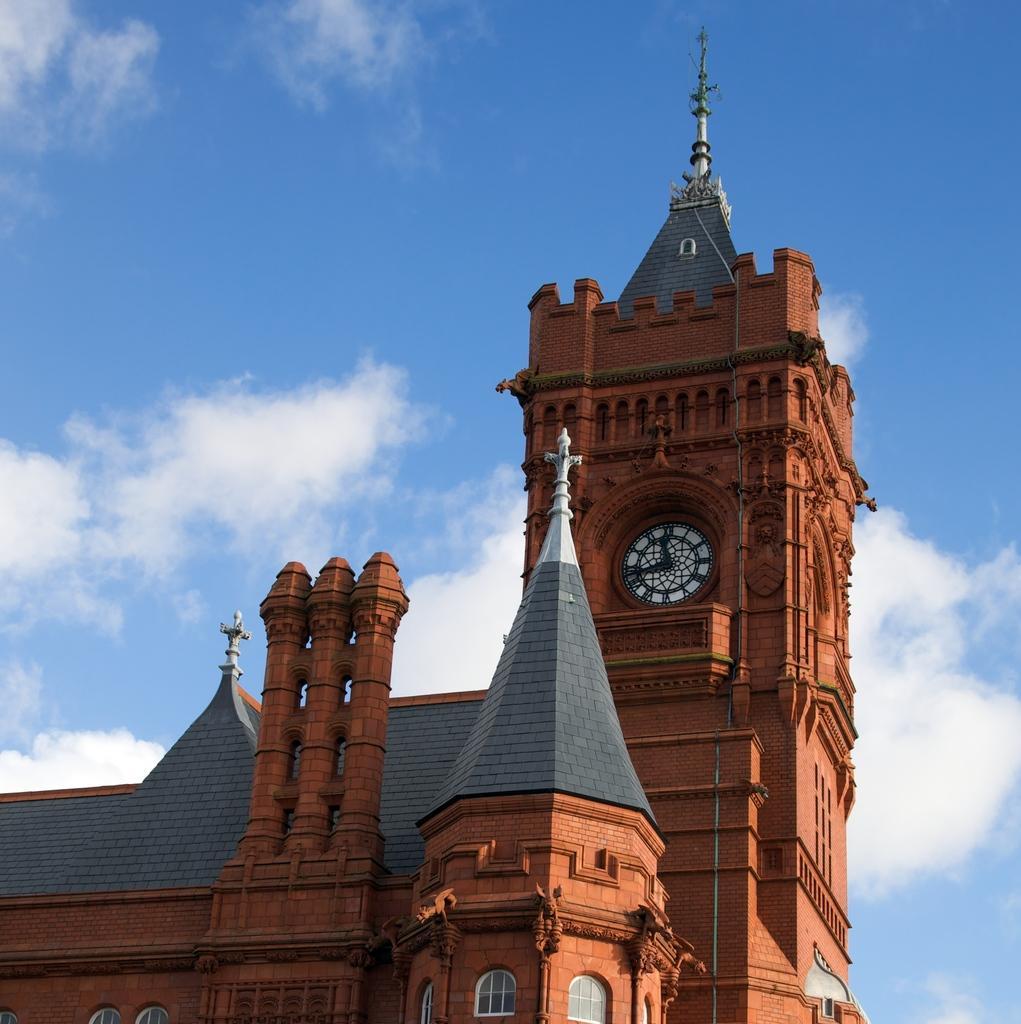In one or two sentences, can you explain what this image depicts? In front of the image there is a clock on the building. In the background of the image there are clouds in the sky. 